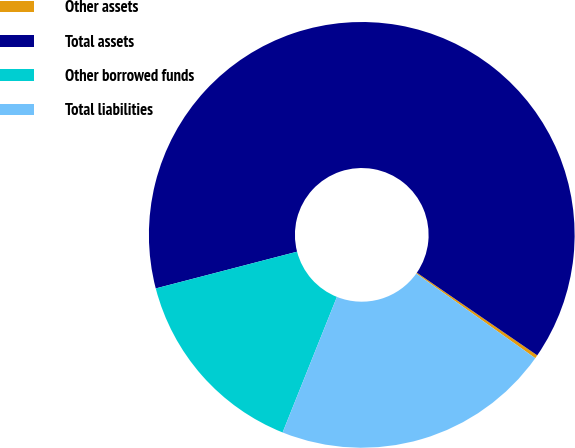Convert chart to OTSL. <chart><loc_0><loc_0><loc_500><loc_500><pie_chart><fcel>Other assets<fcel>Total assets<fcel>Other borrowed funds<fcel>Total liabilities<nl><fcel>0.26%<fcel>63.63%<fcel>14.89%<fcel>21.23%<nl></chart> 